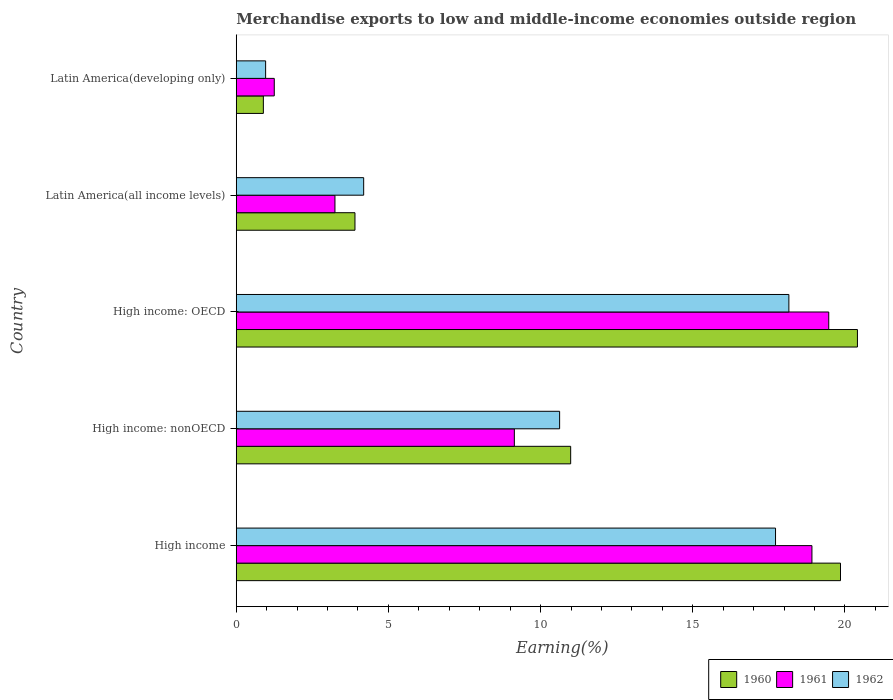How many different coloured bars are there?
Offer a very short reply. 3. How many groups of bars are there?
Give a very brief answer. 5. Are the number of bars per tick equal to the number of legend labels?
Provide a short and direct response. Yes. Are the number of bars on each tick of the Y-axis equal?
Give a very brief answer. Yes. How many bars are there on the 3rd tick from the bottom?
Your response must be concise. 3. What is the label of the 4th group of bars from the top?
Keep it short and to the point. High income: nonOECD. What is the percentage of amount earned from merchandise exports in 1962 in Latin America(all income levels)?
Your answer should be compact. 4.19. Across all countries, what is the maximum percentage of amount earned from merchandise exports in 1962?
Give a very brief answer. 18.16. Across all countries, what is the minimum percentage of amount earned from merchandise exports in 1962?
Keep it short and to the point. 0.97. In which country was the percentage of amount earned from merchandise exports in 1960 maximum?
Ensure brevity in your answer.  High income: OECD. In which country was the percentage of amount earned from merchandise exports in 1960 minimum?
Offer a terse response. Latin America(developing only). What is the total percentage of amount earned from merchandise exports in 1960 in the graph?
Your answer should be very brief. 56.05. What is the difference between the percentage of amount earned from merchandise exports in 1961 in High income: OECD and that in High income: nonOECD?
Your answer should be very brief. 10.33. What is the difference between the percentage of amount earned from merchandise exports in 1961 in High income: OECD and the percentage of amount earned from merchandise exports in 1962 in Latin America(all income levels)?
Ensure brevity in your answer.  15.28. What is the average percentage of amount earned from merchandise exports in 1962 per country?
Provide a succinct answer. 10.33. What is the difference between the percentage of amount earned from merchandise exports in 1962 and percentage of amount earned from merchandise exports in 1961 in Latin America(developing only)?
Provide a short and direct response. -0.28. What is the ratio of the percentage of amount earned from merchandise exports in 1960 in High income: nonOECD to that in Latin America(all income levels)?
Offer a terse response. 2.82. What is the difference between the highest and the second highest percentage of amount earned from merchandise exports in 1960?
Your answer should be very brief. 0.56. What is the difference between the highest and the lowest percentage of amount earned from merchandise exports in 1960?
Make the answer very short. 19.52. In how many countries, is the percentage of amount earned from merchandise exports in 1960 greater than the average percentage of amount earned from merchandise exports in 1960 taken over all countries?
Your response must be concise. 2. Is the sum of the percentage of amount earned from merchandise exports in 1962 in High income: OECD and Latin America(developing only) greater than the maximum percentage of amount earned from merchandise exports in 1961 across all countries?
Your answer should be compact. No. What does the 2nd bar from the bottom in Latin America(all income levels) represents?
Give a very brief answer. 1961. Is it the case that in every country, the sum of the percentage of amount earned from merchandise exports in 1960 and percentage of amount earned from merchandise exports in 1961 is greater than the percentage of amount earned from merchandise exports in 1962?
Give a very brief answer. Yes. Are all the bars in the graph horizontal?
Your answer should be very brief. Yes. How many countries are there in the graph?
Give a very brief answer. 5. What is the difference between two consecutive major ticks on the X-axis?
Give a very brief answer. 5. Does the graph contain any zero values?
Provide a short and direct response. No. How are the legend labels stacked?
Offer a very short reply. Horizontal. What is the title of the graph?
Offer a terse response. Merchandise exports to low and middle-income economies outside region. What is the label or title of the X-axis?
Offer a terse response. Earning(%). What is the Earning(%) of 1960 in High income?
Keep it short and to the point. 19.86. What is the Earning(%) of 1961 in High income?
Keep it short and to the point. 18.92. What is the Earning(%) in 1962 in High income?
Your answer should be very brief. 17.72. What is the Earning(%) in 1960 in High income: nonOECD?
Offer a terse response. 10.99. What is the Earning(%) in 1961 in High income: nonOECD?
Make the answer very short. 9.14. What is the Earning(%) of 1962 in High income: nonOECD?
Provide a succinct answer. 10.63. What is the Earning(%) of 1960 in High income: OECD?
Your answer should be very brief. 20.41. What is the Earning(%) in 1961 in High income: OECD?
Your answer should be compact. 19.47. What is the Earning(%) in 1962 in High income: OECD?
Ensure brevity in your answer.  18.16. What is the Earning(%) in 1960 in Latin America(all income levels)?
Your answer should be very brief. 3.9. What is the Earning(%) in 1961 in Latin America(all income levels)?
Give a very brief answer. 3.24. What is the Earning(%) of 1962 in Latin America(all income levels)?
Ensure brevity in your answer.  4.19. What is the Earning(%) of 1960 in Latin America(developing only)?
Your answer should be compact. 0.89. What is the Earning(%) of 1961 in Latin America(developing only)?
Offer a terse response. 1.25. What is the Earning(%) in 1962 in Latin America(developing only)?
Your response must be concise. 0.97. Across all countries, what is the maximum Earning(%) in 1960?
Make the answer very short. 20.41. Across all countries, what is the maximum Earning(%) of 1961?
Your answer should be compact. 19.47. Across all countries, what is the maximum Earning(%) of 1962?
Offer a very short reply. 18.16. Across all countries, what is the minimum Earning(%) of 1960?
Keep it short and to the point. 0.89. Across all countries, what is the minimum Earning(%) in 1961?
Make the answer very short. 1.25. Across all countries, what is the minimum Earning(%) in 1962?
Provide a succinct answer. 0.97. What is the total Earning(%) of 1960 in the graph?
Make the answer very short. 56.05. What is the total Earning(%) of 1961 in the graph?
Give a very brief answer. 52.02. What is the total Earning(%) of 1962 in the graph?
Offer a terse response. 51.66. What is the difference between the Earning(%) of 1960 in High income and that in High income: nonOECD?
Keep it short and to the point. 8.87. What is the difference between the Earning(%) of 1961 in High income and that in High income: nonOECD?
Provide a short and direct response. 9.78. What is the difference between the Earning(%) in 1962 in High income and that in High income: nonOECD?
Offer a very short reply. 7.1. What is the difference between the Earning(%) of 1960 in High income and that in High income: OECD?
Keep it short and to the point. -0.56. What is the difference between the Earning(%) in 1961 in High income and that in High income: OECD?
Provide a short and direct response. -0.55. What is the difference between the Earning(%) in 1962 in High income and that in High income: OECD?
Your answer should be very brief. -0.44. What is the difference between the Earning(%) of 1960 in High income and that in Latin America(all income levels)?
Ensure brevity in your answer.  15.95. What is the difference between the Earning(%) in 1961 in High income and that in Latin America(all income levels)?
Your answer should be compact. 15.67. What is the difference between the Earning(%) in 1962 in High income and that in Latin America(all income levels)?
Keep it short and to the point. 13.53. What is the difference between the Earning(%) in 1960 in High income and that in Latin America(developing only)?
Offer a terse response. 18.97. What is the difference between the Earning(%) of 1961 in High income and that in Latin America(developing only)?
Provide a short and direct response. 17.67. What is the difference between the Earning(%) in 1962 in High income and that in Latin America(developing only)?
Give a very brief answer. 16.76. What is the difference between the Earning(%) in 1960 in High income: nonOECD and that in High income: OECD?
Keep it short and to the point. -9.42. What is the difference between the Earning(%) of 1961 in High income: nonOECD and that in High income: OECD?
Your answer should be compact. -10.33. What is the difference between the Earning(%) of 1962 in High income: nonOECD and that in High income: OECD?
Give a very brief answer. -7.53. What is the difference between the Earning(%) of 1960 in High income: nonOECD and that in Latin America(all income levels)?
Ensure brevity in your answer.  7.09. What is the difference between the Earning(%) in 1961 in High income: nonOECD and that in Latin America(all income levels)?
Ensure brevity in your answer.  5.9. What is the difference between the Earning(%) of 1962 in High income: nonOECD and that in Latin America(all income levels)?
Your response must be concise. 6.44. What is the difference between the Earning(%) in 1960 in High income: nonOECD and that in Latin America(developing only)?
Your answer should be very brief. 10.1. What is the difference between the Earning(%) of 1961 in High income: nonOECD and that in Latin America(developing only)?
Provide a succinct answer. 7.89. What is the difference between the Earning(%) in 1962 in High income: nonOECD and that in Latin America(developing only)?
Make the answer very short. 9.66. What is the difference between the Earning(%) of 1960 in High income: OECD and that in Latin America(all income levels)?
Offer a terse response. 16.51. What is the difference between the Earning(%) in 1961 in High income: OECD and that in Latin America(all income levels)?
Offer a terse response. 16.23. What is the difference between the Earning(%) of 1962 in High income: OECD and that in Latin America(all income levels)?
Your response must be concise. 13.97. What is the difference between the Earning(%) in 1960 in High income: OECD and that in Latin America(developing only)?
Make the answer very short. 19.52. What is the difference between the Earning(%) in 1961 in High income: OECD and that in Latin America(developing only)?
Offer a very short reply. 18.22. What is the difference between the Earning(%) in 1962 in High income: OECD and that in Latin America(developing only)?
Make the answer very short. 17.19. What is the difference between the Earning(%) in 1960 in Latin America(all income levels) and that in Latin America(developing only)?
Offer a terse response. 3.01. What is the difference between the Earning(%) of 1961 in Latin America(all income levels) and that in Latin America(developing only)?
Keep it short and to the point. 1.99. What is the difference between the Earning(%) in 1962 in Latin America(all income levels) and that in Latin America(developing only)?
Provide a short and direct response. 3.22. What is the difference between the Earning(%) in 1960 in High income and the Earning(%) in 1961 in High income: nonOECD?
Make the answer very short. 10.72. What is the difference between the Earning(%) of 1960 in High income and the Earning(%) of 1962 in High income: nonOECD?
Give a very brief answer. 9.23. What is the difference between the Earning(%) in 1961 in High income and the Earning(%) in 1962 in High income: nonOECD?
Your response must be concise. 8.29. What is the difference between the Earning(%) of 1960 in High income and the Earning(%) of 1961 in High income: OECD?
Offer a terse response. 0.39. What is the difference between the Earning(%) in 1960 in High income and the Earning(%) in 1962 in High income: OECD?
Offer a terse response. 1.7. What is the difference between the Earning(%) in 1961 in High income and the Earning(%) in 1962 in High income: OECD?
Keep it short and to the point. 0.76. What is the difference between the Earning(%) of 1960 in High income and the Earning(%) of 1961 in Latin America(all income levels)?
Provide a short and direct response. 16.61. What is the difference between the Earning(%) in 1960 in High income and the Earning(%) in 1962 in Latin America(all income levels)?
Offer a terse response. 15.67. What is the difference between the Earning(%) in 1961 in High income and the Earning(%) in 1962 in Latin America(all income levels)?
Provide a succinct answer. 14.73. What is the difference between the Earning(%) of 1960 in High income and the Earning(%) of 1961 in Latin America(developing only)?
Your answer should be very brief. 18.61. What is the difference between the Earning(%) of 1960 in High income and the Earning(%) of 1962 in Latin America(developing only)?
Make the answer very short. 18.89. What is the difference between the Earning(%) in 1961 in High income and the Earning(%) in 1962 in Latin America(developing only)?
Offer a terse response. 17.95. What is the difference between the Earning(%) of 1960 in High income: nonOECD and the Earning(%) of 1961 in High income: OECD?
Your answer should be compact. -8.48. What is the difference between the Earning(%) of 1960 in High income: nonOECD and the Earning(%) of 1962 in High income: OECD?
Give a very brief answer. -7.17. What is the difference between the Earning(%) in 1961 in High income: nonOECD and the Earning(%) in 1962 in High income: OECD?
Your answer should be compact. -9.02. What is the difference between the Earning(%) of 1960 in High income: nonOECD and the Earning(%) of 1961 in Latin America(all income levels)?
Keep it short and to the point. 7.75. What is the difference between the Earning(%) of 1960 in High income: nonOECD and the Earning(%) of 1962 in Latin America(all income levels)?
Provide a short and direct response. 6.8. What is the difference between the Earning(%) in 1961 in High income: nonOECD and the Earning(%) in 1962 in Latin America(all income levels)?
Make the answer very short. 4.95. What is the difference between the Earning(%) of 1960 in High income: nonOECD and the Earning(%) of 1961 in Latin America(developing only)?
Provide a short and direct response. 9.74. What is the difference between the Earning(%) of 1960 in High income: nonOECD and the Earning(%) of 1962 in Latin America(developing only)?
Your answer should be compact. 10.02. What is the difference between the Earning(%) of 1961 in High income: nonOECD and the Earning(%) of 1962 in Latin America(developing only)?
Provide a succinct answer. 8.17. What is the difference between the Earning(%) of 1960 in High income: OECD and the Earning(%) of 1961 in Latin America(all income levels)?
Your response must be concise. 17.17. What is the difference between the Earning(%) of 1960 in High income: OECD and the Earning(%) of 1962 in Latin America(all income levels)?
Your answer should be compact. 16.23. What is the difference between the Earning(%) of 1961 in High income: OECD and the Earning(%) of 1962 in Latin America(all income levels)?
Provide a short and direct response. 15.28. What is the difference between the Earning(%) in 1960 in High income: OECD and the Earning(%) in 1961 in Latin America(developing only)?
Offer a very short reply. 19.16. What is the difference between the Earning(%) in 1960 in High income: OECD and the Earning(%) in 1962 in Latin America(developing only)?
Your response must be concise. 19.45. What is the difference between the Earning(%) of 1961 in High income: OECD and the Earning(%) of 1962 in Latin America(developing only)?
Ensure brevity in your answer.  18.5. What is the difference between the Earning(%) in 1960 in Latin America(all income levels) and the Earning(%) in 1961 in Latin America(developing only)?
Give a very brief answer. 2.65. What is the difference between the Earning(%) in 1960 in Latin America(all income levels) and the Earning(%) in 1962 in Latin America(developing only)?
Your answer should be compact. 2.94. What is the difference between the Earning(%) of 1961 in Latin America(all income levels) and the Earning(%) of 1962 in Latin America(developing only)?
Make the answer very short. 2.28. What is the average Earning(%) in 1960 per country?
Your response must be concise. 11.21. What is the average Earning(%) of 1961 per country?
Offer a terse response. 10.4. What is the average Earning(%) of 1962 per country?
Your response must be concise. 10.33. What is the difference between the Earning(%) in 1960 and Earning(%) in 1961 in High income?
Provide a succinct answer. 0.94. What is the difference between the Earning(%) in 1960 and Earning(%) in 1962 in High income?
Make the answer very short. 2.13. What is the difference between the Earning(%) in 1961 and Earning(%) in 1962 in High income?
Your answer should be compact. 1.2. What is the difference between the Earning(%) of 1960 and Earning(%) of 1961 in High income: nonOECD?
Your answer should be compact. 1.85. What is the difference between the Earning(%) of 1960 and Earning(%) of 1962 in High income: nonOECD?
Provide a short and direct response. 0.36. What is the difference between the Earning(%) of 1961 and Earning(%) of 1962 in High income: nonOECD?
Give a very brief answer. -1.49. What is the difference between the Earning(%) of 1960 and Earning(%) of 1961 in High income: OECD?
Ensure brevity in your answer.  0.94. What is the difference between the Earning(%) in 1960 and Earning(%) in 1962 in High income: OECD?
Your answer should be compact. 2.25. What is the difference between the Earning(%) of 1961 and Earning(%) of 1962 in High income: OECD?
Make the answer very short. 1.31. What is the difference between the Earning(%) in 1960 and Earning(%) in 1961 in Latin America(all income levels)?
Your answer should be compact. 0.66. What is the difference between the Earning(%) in 1960 and Earning(%) in 1962 in Latin America(all income levels)?
Give a very brief answer. -0.29. What is the difference between the Earning(%) of 1961 and Earning(%) of 1962 in Latin America(all income levels)?
Give a very brief answer. -0.94. What is the difference between the Earning(%) of 1960 and Earning(%) of 1961 in Latin America(developing only)?
Your answer should be compact. -0.36. What is the difference between the Earning(%) in 1960 and Earning(%) in 1962 in Latin America(developing only)?
Keep it short and to the point. -0.07. What is the difference between the Earning(%) of 1961 and Earning(%) of 1962 in Latin America(developing only)?
Your answer should be very brief. 0.28. What is the ratio of the Earning(%) of 1960 in High income to that in High income: nonOECD?
Provide a short and direct response. 1.81. What is the ratio of the Earning(%) of 1961 in High income to that in High income: nonOECD?
Offer a very short reply. 2.07. What is the ratio of the Earning(%) in 1962 in High income to that in High income: nonOECD?
Your answer should be very brief. 1.67. What is the ratio of the Earning(%) in 1960 in High income to that in High income: OECD?
Offer a very short reply. 0.97. What is the ratio of the Earning(%) of 1961 in High income to that in High income: OECD?
Keep it short and to the point. 0.97. What is the ratio of the Earning(%) in 1962 in High income to that in High income: OECD?
Provide a succinct answer. 0.98. What is the ratio of the Earning(%) of 1960 in High income to that in Latin America(all income levels)?
Provide a short and direct response. 5.09. What is the ratio of the Earning(%) in 1961 in High income to that in Latin America(all income levels)?
Your answer should be compact. 5.83. What is the ratio of the Earning(%) of 1962 in High income to that in Latin America(all income levels)?
Provide a short and direct response. 4.23. What is the ratio of the Earning(%) in 1960 in High income to that in Latin America(developing only)?
Your answer should be compact. 22.3. What is the ratio of the Earning(%) of 1961 in High income to that in Latin America(developing only)?
Provide a short and direct response. 15.15. What is the ratio of the Earning(%) of 1962 in High income to that in Latin America(developing only)?
Provide a succinct answer. 18.36. What is the ratio of the Earning(%) of 1960 in High income: nonOECD to that in High income: OECD?
Provide a short and direct response. 0.54. What is the ratio of the Earning(%) in 1961 in High income: nonOECD to that in High income: OECD?
Give a very brief answer. 0.47. What is the ratio of the Earning(%) of 1962 in High income: nonOECD to that in High income: OECD?
Make the answer very short. 0.59. What is the ratio of the Earning(%) in 1960 in High income: nonOECD to that in Latin America(all income levels)?
Your response must be concise. 2.82. What is the ratio of the Earning(%) of 1961 in High income: nonOECD to that in Latin America(all income levels)?
Offer a terse response. 2.82. What is the ratio of the Earning(%) in 1962 in High income: nonOECD to that in Latin America(all income levels)?
Keep it short and to the point. 2.54. What is the ratio of the Earning(%) in 1960 in High income: nonOECD to that in Latin America(developing only)?
Keep it short and to the point. 12.34. What is the ratio of the Earning(%) of 1961 in High income: nonOECD to that in Latin America(developing only)?
Your answer should be compact. 7.32. What is the ratio of the Earning(%) in 1962 in High income: nonOECD to that in Latin America(developing only)?
Ensure brevity in your answer.  11.01. What is the ratio of the Earning(%) in 1960 in High income: OECD to that in Latin America(all income levels)?
Offer a terse response. 5.23. What is the ratio of the Earning(%) of 1961 in High income: OECD to that in Latin America(all income levels)?
Provide a succinct answer. 6. What is the ratio of the Earning(%) in 1962 in High income: OECD to that in Latin America(all income levels)?
Provide a succinct answer. 4.34. What is the ratio of the Earning(%) of 1960 in High income: OECD to that in Latin America(developing only)?
Provide a succinct answer. 22.92. What is the ratio of the Earning(%) in 1961 in High income: OECD to that in Latin America(developing only)?
Keep it short and to the point. 15.59. What is the ratio of the Earning(%) in 1962 in High income: OECD to that in Latin America(developing only)?
Provide a succinct answer. 18.82. What is the ratio of the Earning(%) in 1960 in Latin America(all income levels) to that in Latin America(developing only)?
Your answer should be very brief. 4.38. What is the ratio of the Earning(%) in 1961 in Latin America(all income levels) to that in Latin America(developing only)?
Ensure brevity in your answer.  2.6. What is the ratio of the Earning(%) of 1962 in Latin America(all income levels) to that in Latin America(developing only)?
Provide a succinct answer. 4.34. What is the difference between the highest and the second highest Earning(%) of 1960?
Your answer should be compact. 0.56. What is the difference between the highest and the second highest Earning(%) in 1961?
Ensure brevity in your answer.  0.55. What is the difference between the highest and the second highest Earning(%) in 1962?
Your answer should be compact. 0.44. What is the difference between the highest and the lowest Earning(%) in 1960?
Keep it short and to the point. 19.52. What is the difference between the highest and the lowest Earning(%) in 1961?
Offer a very short reply. 18.22. What is the difference between the highest and the lowest Earning(%) in 1962?
Your answer should be compact. 17.19. 